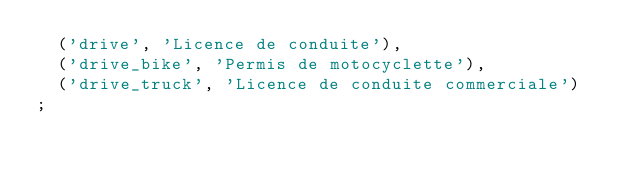<code> <loc_0><loc_0><loc_500><loc_500><_SQL_>	('drive', 'Licence de conduite'),
	('drive_bike', 'Permis de motocyclette'),
	('drive_truck', 'Licence de conduite commerciale')
;
</code> 